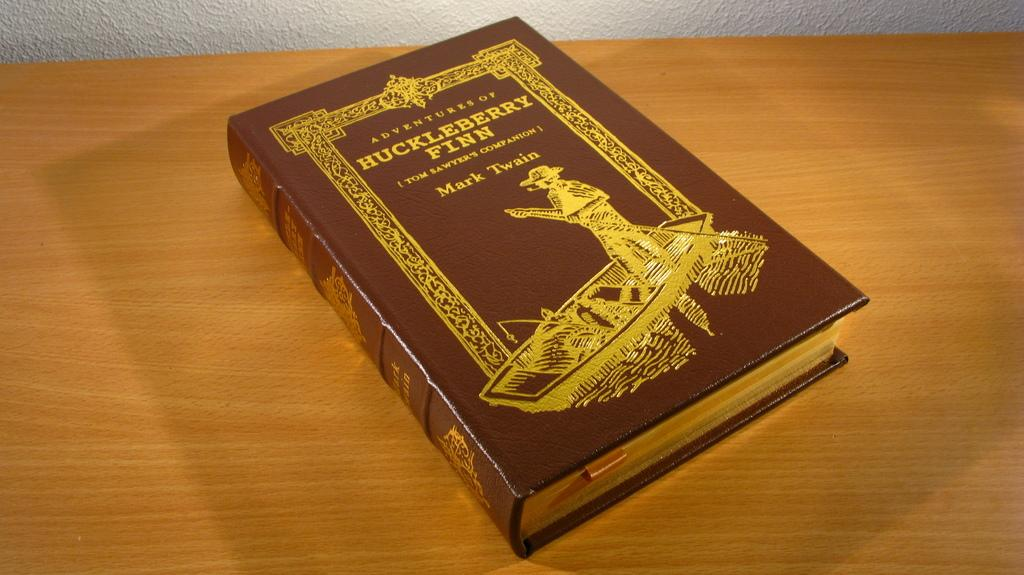<image>
Offer a succinct explanation of the picture presented. A nice hardcover copy of Huckleberry Finn by Mark Twain on a desk. 